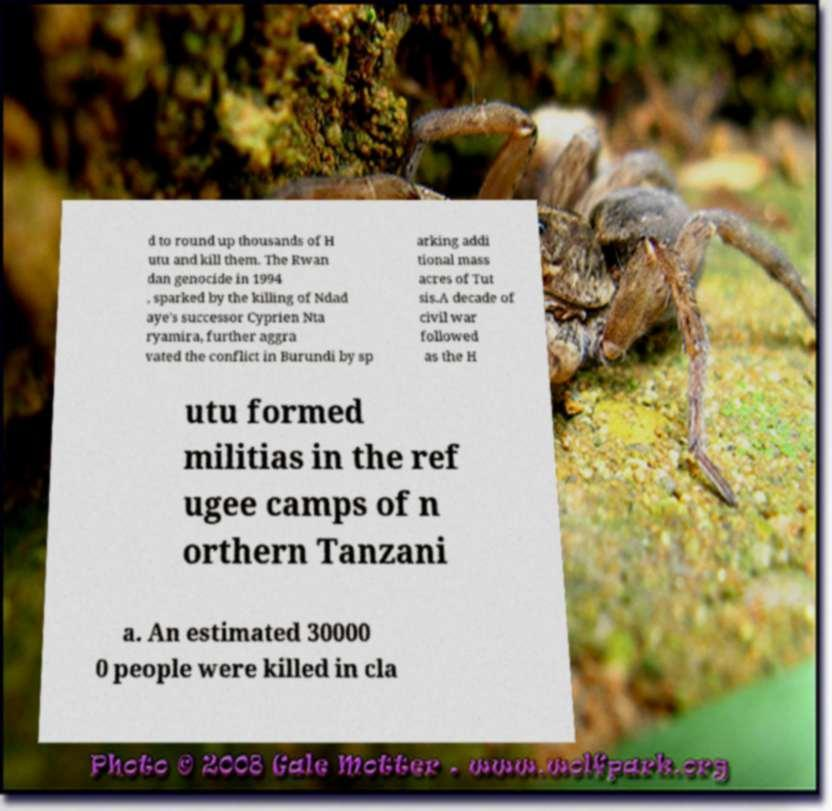Could you extract and type out the text from this image? d to round up thousands of H utu and kill them. The Rwan dan genocide in 1994 , sparked by the killing of Ndad aye's successor Cyprien Nta ryamira, further aggra vated the conflict in Burundi by sp arking addi tional mass acres of Tut sis.A decade of civil war followed as the H utu formed militias in the ref ugee camps of n orthern Tanzani a. An estimated 30000 0 people were killed in cla 